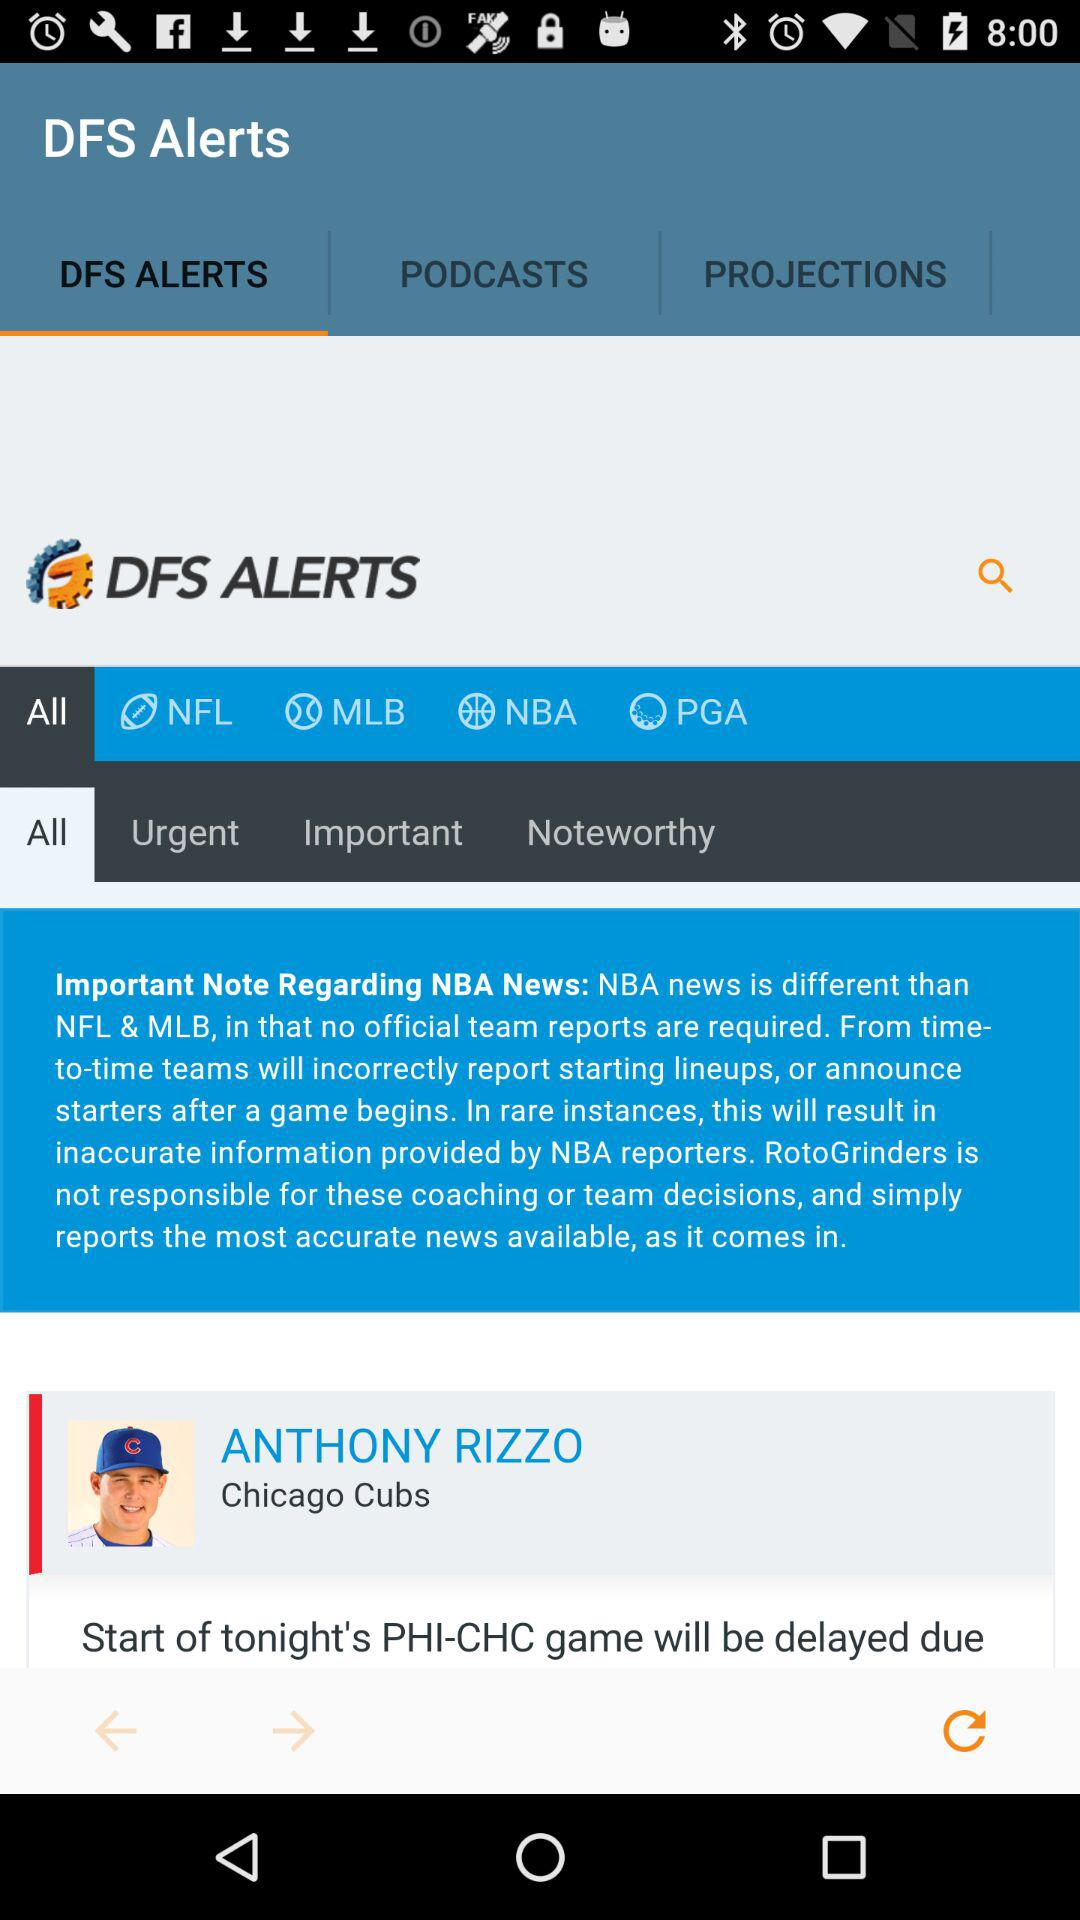What is the app name? The app name is "RotoGrinders DFS Alerts". 